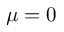<formula> <loc_0><loc_0><loc_500><loc_500>\mu = 0</formula> 